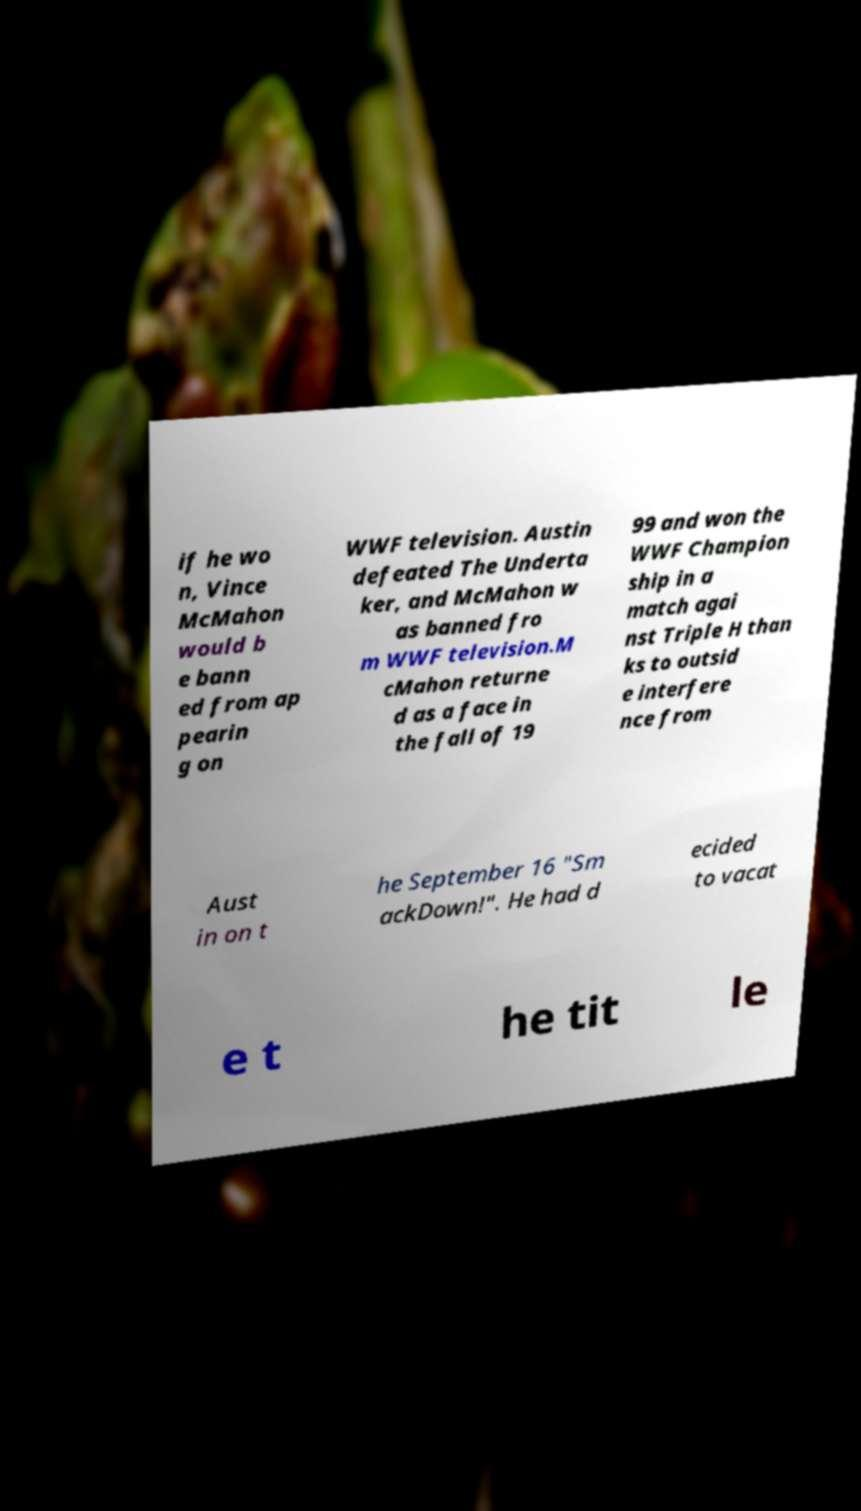Could you assist in decoding the text presented in this image and type it out clearly? if he wo n, Vince McMahon would b e bann ed from ap pearin g on WWF television. Austin defeated The Underta ker, and McMahon w as banned fro m WWF television.M cMahon returne d as a face in the fall of 19 99 and won the WWF Champion ship in a match agai nst Triple H than ks to outsid e interfere nce from Aust in on t he September 16 "Sm ackDown!". He had d ecided to vacat e t he tit le 